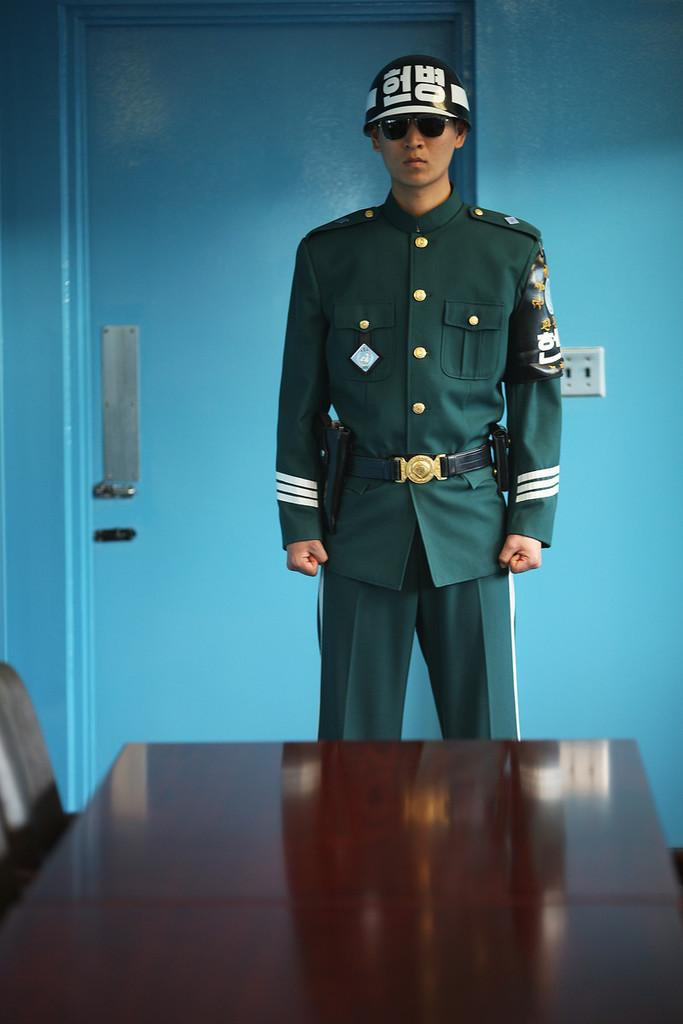Who is present in the image? There is a man in the image. What is the man wearing? The man is wearing a uniform and cap. What furniture can be seen in the image? There is a table and a chair in the image. What can be seen in the background of the image? There is a wall, a door, and a switch board in the background of the image. What type of curve can be seen in the image? There is no curve present in the image. What crime is the man committing in the image? There is no crime being committed in the image; the man is simply wearing a uniform and cap. 